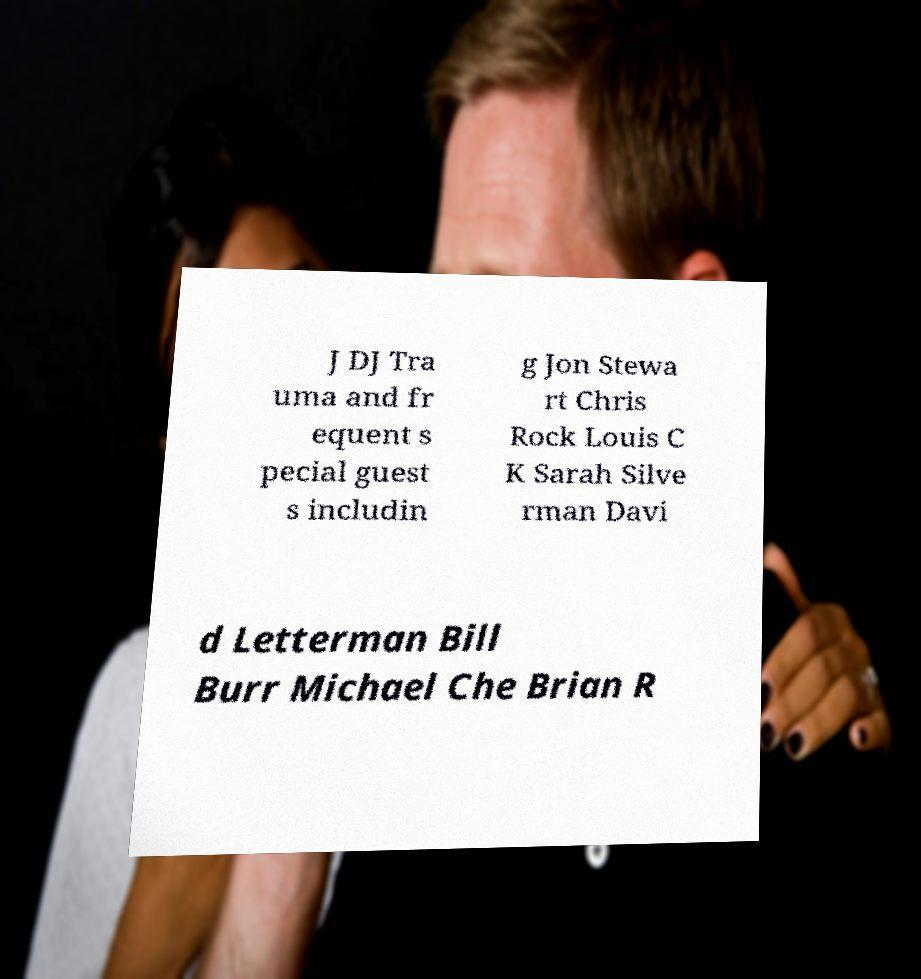Please identify and transcribe the text found in this image. J DJ Tra uma and fr equent s pecial guest s includin g Jon Stewa rt Chris Rock Louis C K Sarah Silve rman Davi d Letterman Bill Burr Michael Che Brian R 